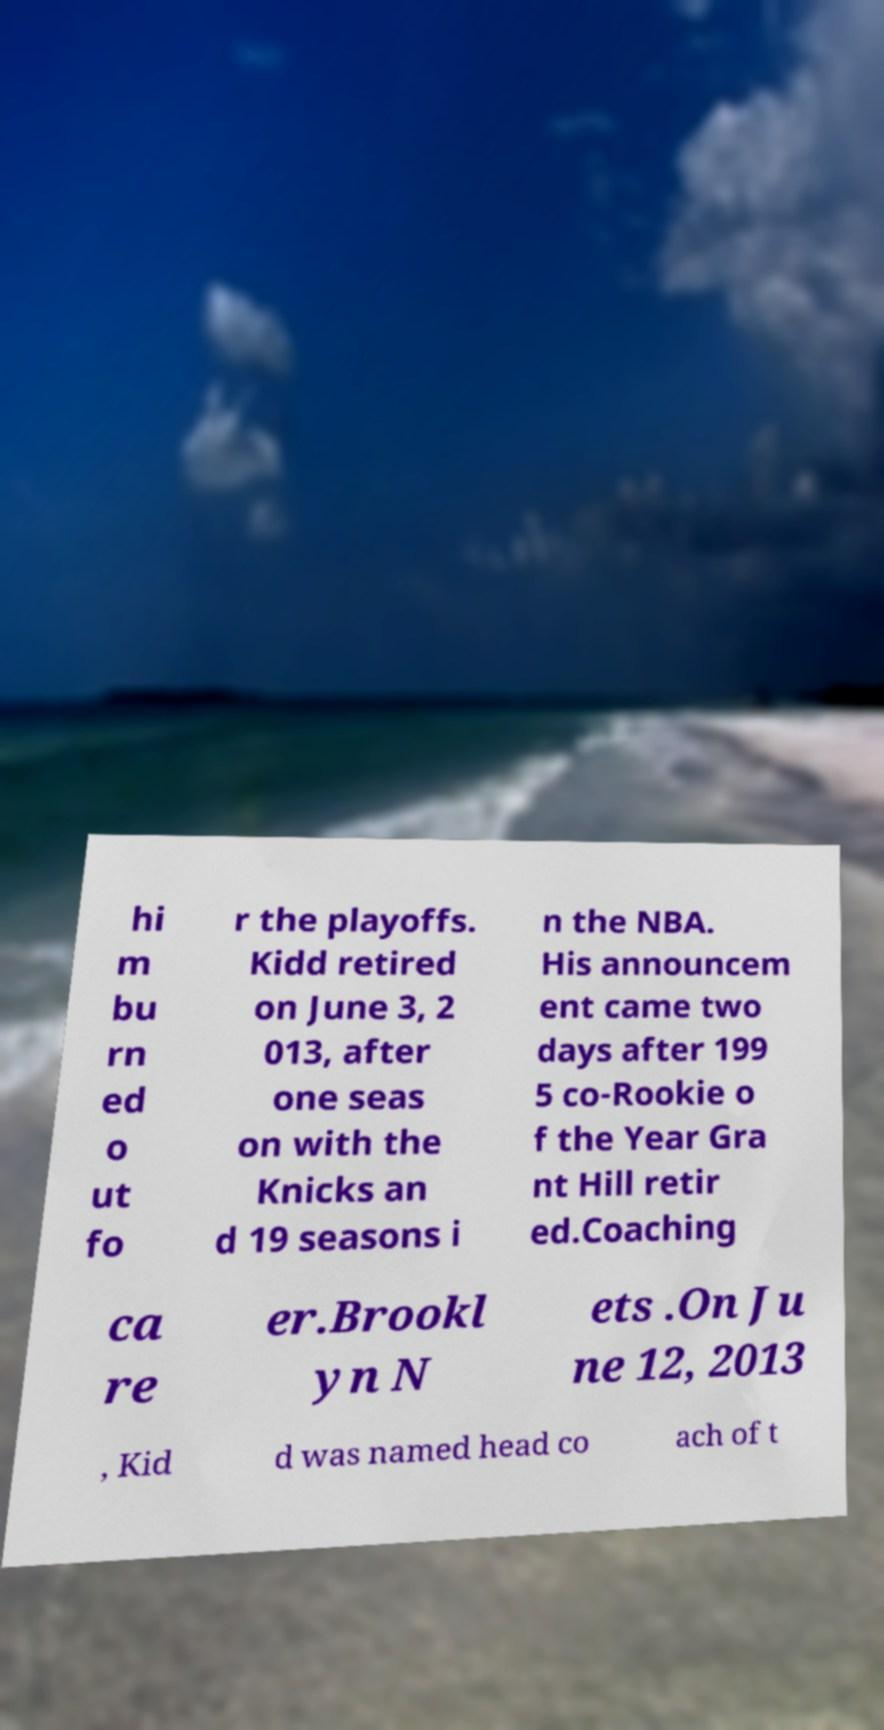Could you extract and type out the text from this image? hi m bu rn ed o ut fo r the playoffs. Kidd retired on June 3, 2 013, after one seas on with the Knicks an d 19 seasons i n the NBA. His announcem ent came two days after 199 5 co-Rookie o f the Year Gra nt Hill retir ed.Coaching ca re er.Brookl yn N ets .On Ju ne 12, 2013 , Kid d was named head co ach of t 